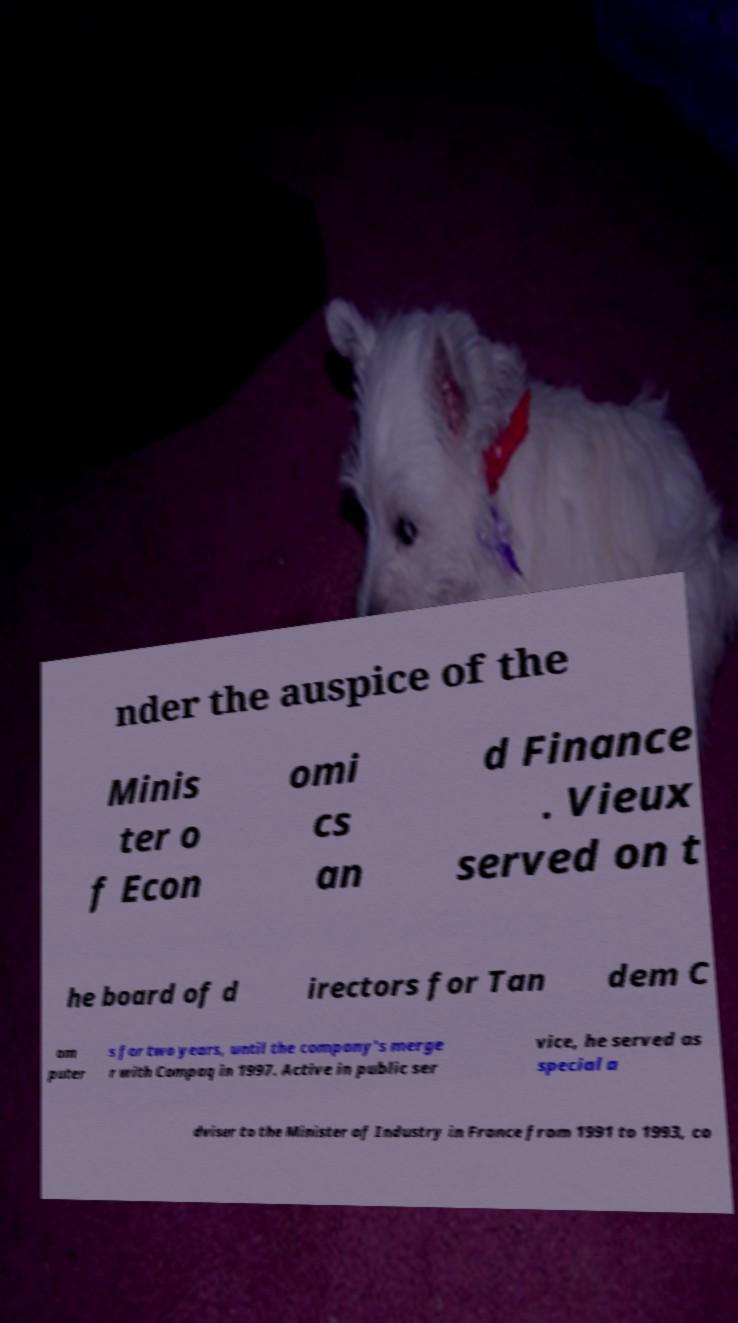Could you assist in decoding the text presented in this image and type it out clearly? nder the auspice of the Minis ter o f Econ omi cs an d Finance . Vieux served on t he board of d irectors for Tan dem C om puter s for two years, until the company's merge r with Compaq in 1997. Active in public ser vice, he served as special a dviser to the Minister of Industry in France from 1991 to 1993, co 